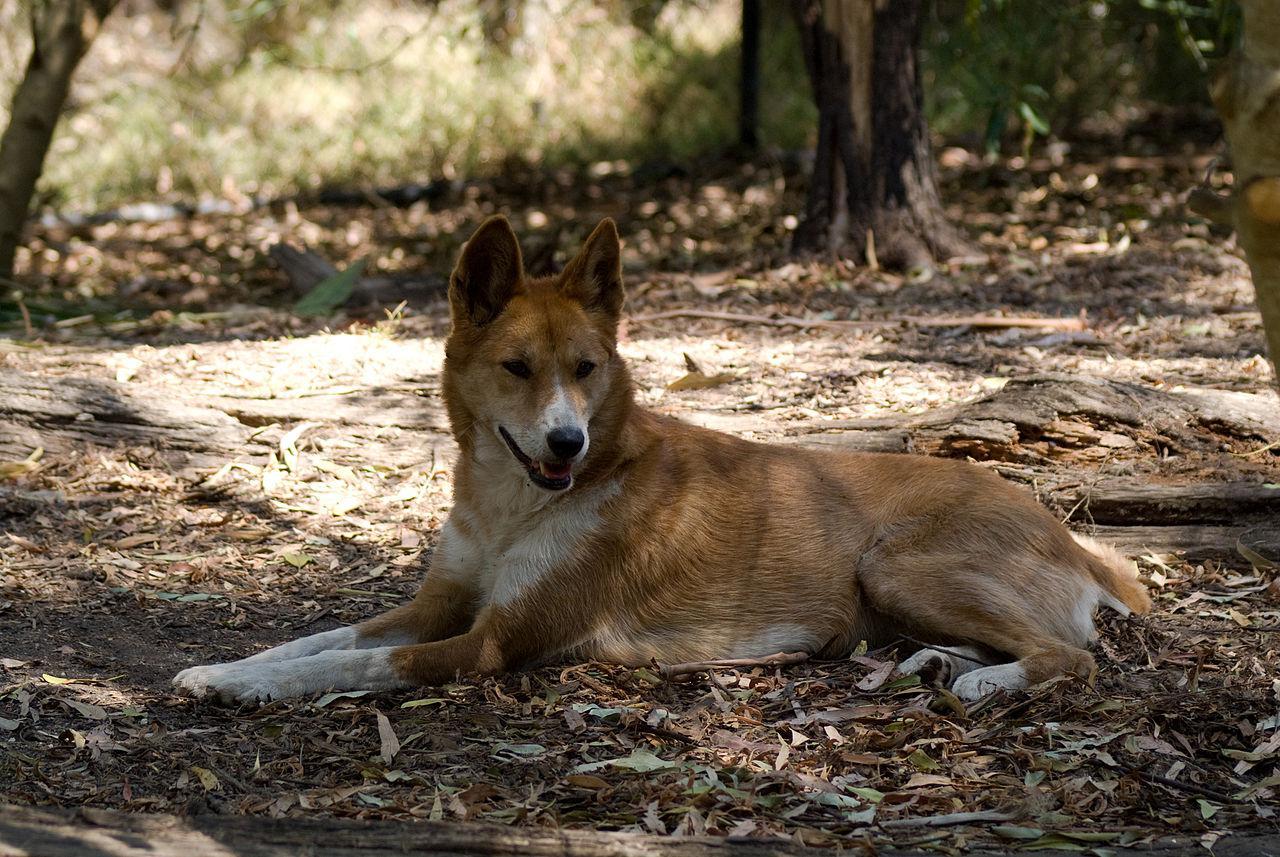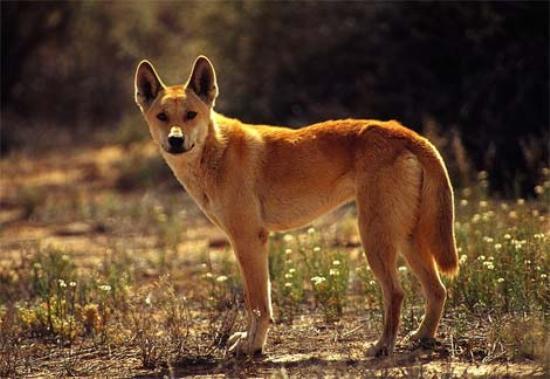The first image is the image on the left, the second image is the image on the right. For the images shown, is this caption "There are two animals in total." true? Answer yes or no. Yes. The first image is the image on the left, the second image is the image on the right. Examine the images to the left and right. Is the description "The left image contains at least two dingos." accurate? Answer yes or no. No. 